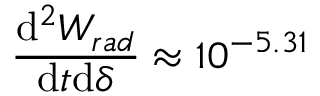Convert formula to latex. <formula><loc_0><loc_0><loc_500><loc_500>\frac { d ^ { 2 } W _ { r a d } } { d t d \delta } \approx 1 0 ^ { - 5 . 3 1 }</formula> 